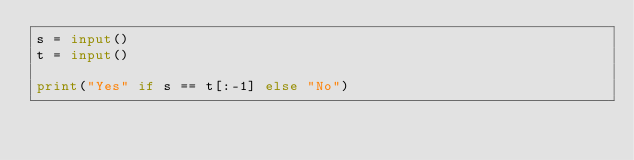Convert code to text. <code><loc_0><loc_0><loc_500><loc_500><_Python_>s = input()
t = input()

print("Yes" if s == t[:-1] else "No")</code> 